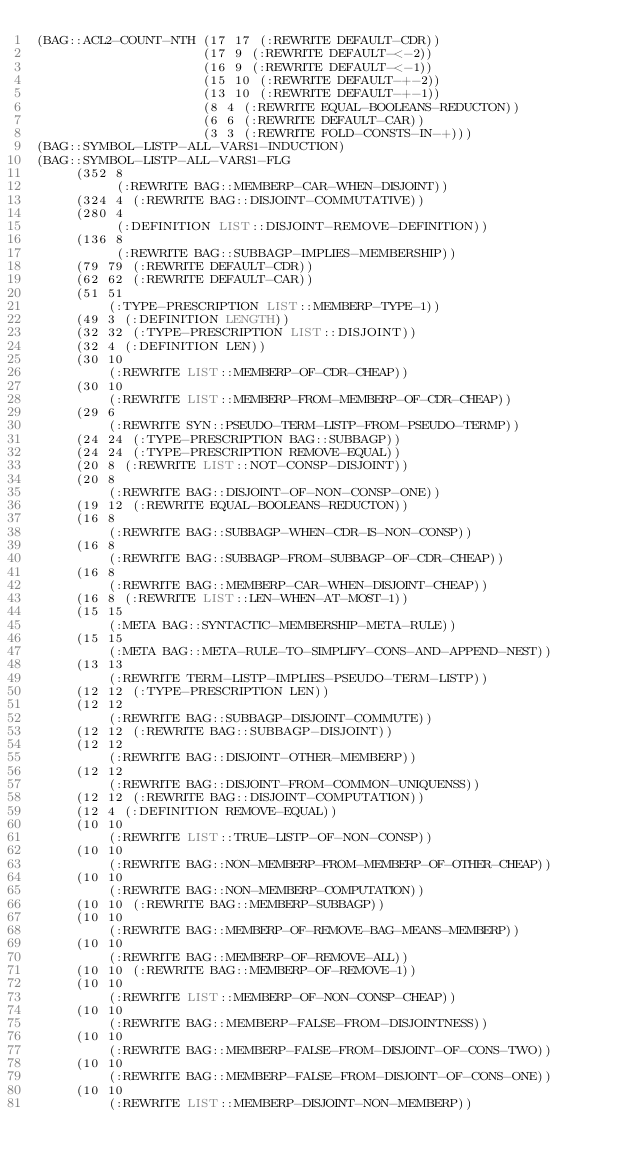<code> <loc_0><loc_0><loc_500><loc_500><_Lisp_>(BAG::ACL2-COUNT-NTH (17 17 (:REWRITE DEFAULT-CDR))
                     (17 9 (:REWRITE DEFAULT-<-2))
                     (16 9 (:REWRITE DEFAULT-<-1))
                     (15 10 (:REWRITE DEFAULT-+-2))
                     (13 10 (:REWRITE DEFAULT-+-1))
                     (8 4 (:REWRITE EQUAL-BOOLEANS-REDUCTON))
                     (6 6 (:REWRITE DEFAULT-CAR))
                     (3 3 (:REWRITE FOLD-CONSTS-IN-+)))
(BAG::SYMBOL-LISTP-ALL-VARS1-INDUCTION)
(BAG::SYMBOL-LISTP-ALL-VARS1-FLG
     (352 8
          (:REWRITE BAG::MEMBERP-CAR-WHEN-DISJOINT))
     (324 4 (:REWRITE BAG::DISJOINT-COMMUTATIVE))
     (280 4
          (:DEFINITION LIST::DISJOINT-REMOVE-DEFINITION))
     (136 8
          (:REWRITE BAG::SUBBAGP-IMPLIES-MEMBERSHIP))
     (79 79 (:REWRITE DEFAULT-CDR))
     (62 62 (:REWRITE DEFAULT-CAR))
     (51 51
         (:TYPE-PRESCRIPTION LIST::MEMBERP-TYPE-1))
     (49 3 (:DEFINITION LENGTH))
     (32 32 (:TYPE-PRESCRIPTION LIST::DISJOINT))
     (32 4 (:DEFINITION LEN))
     (30 10
         (:REWRITE LIST::MEMBERP-OF-CDR-CHEAP))
     (30 10
         (:REWRITE LIST::MEMBERP-FROM-MEMBERP-OF-CDR-CHEAP))
     (29 6
         (:REWRITE SYN::PSEUDO-TERM-LISTP-FROM-PSEUDO-TERMP))
     (24 24 (:TYPE-PRESCRIPTION BAG::SUBBAGP))
     (24 24 (:TYPE-PRESCRIPTION REMOVE-EQUAL))
     (20 8 (:REWRITE LIST::NOT-CONSP-DISJOINT))
     (20 8
         (:REWRITE BAG::DISJOINT-OF-NON-CONSP-ONE))
     (19 12 (:REWRITE EQUAL-BOOLEANS-REDUCTON))
     (16 8
         (:REWRITE BAG::SUBBAGP-WHEN-CDR-IS-NON-CONSP))
     (16 8
         (:REWRITE BAG::SUBBAGP-FROM-SUBBAGP-OF-CDR-CHEAP))
     (16 8
         (:REWRITE BAG::MEMBERP-CAR-WHEN-DISJOINT-CHEAP))
     (16 8 (:REWRITE LIST::LEN-WHEN-AT-MOST-1))
     (15 15
         (:META BAG::SYNTACTIC-MEMBERSHIP-META-RULE))
     (15 15
         (:META BAG::META-RULE-TO-SIMPLIFY-CONS-AND-APPEND-NEST))
     (13 13
         (:REWRITE TERM-LISTP-IMPLIES-PSEUDO-TERM-LISTP))
     (12 12 (:TYPE-PRESCRIPTION LEN))
     (12 12
         (:REWRITE BAG::SUBBAGP-DISJOINT-COMMUTE))
     (12 12 (:REWRITE BAG::SUBBAGP-DISJOINT))
     (12 12
         (:REWRITE BAG::DISJOINT-OTHER-MEMBERP))
     (12 12
         (:REWRITE BAG::DISJOINT-FROM-COMMON-UNIQUENSS))
     (12 12 (:REWRITE BAG::DISJOINT-COMPUTATION))
     (12 4 (:DEFINITION REMOVE-EQUAL))
     (10 10
         (:REWRITE LIST::TRUE-LISTP-OF-NON-CONSP))
     (10 10
         (:REWRITE BAG::NON-MEMBERP-FROM-MEMBERP-OF-OTHER-CHEAP))
     (10 10
         (:REWRITE BAG::NON-MEMBERP-COMPUTATION))
     (10 10 (:REWRITE BAG::MEMBERP-SUBBAGP))
     (10 10
         (:REWRITE BAG::MEMBERP-OF-REMOVE-BAG-MEANS-MEMBERP))
     (10 10
         (:REWRITE BAG::MEMBERP-OF-REMOVE-ALL))
     (10 10 (:REWRITE BAG::MEMBERP-OF-REMOVE-1))
     (10 10
         (:REWRITE LIST::MEMBERP-OF-NON-CONSP-CHEAP))
     (10 10
         (:REWRITE BAG::MEMBERP-FALSE-FROM-DISJOINTNESS))
     (10 10
         (:REWRITE BAG::MEMBERP-FALSE-FROM-DISJOINT-OF-CONS-TWO))
     (10 10
         (:REWRITE BAG::MEMBERP-FALSE-FROM-DISJOINT-OF-CONS-ONE))
     (10 10
         (:REWRITE LIST::MEMBERP-DISJOINT-NON-MEMBERP))</code> 